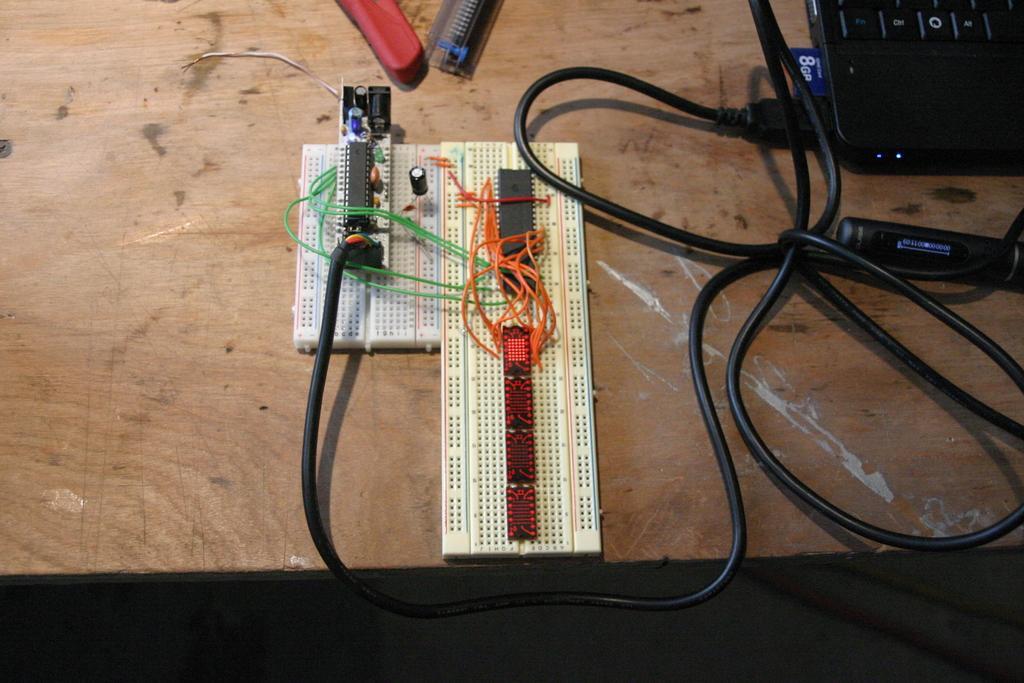How would you summarize this image in a sentence or two? In the center of this picture we can see the bread boards, wires, cable, laptop and some other objects are placed on the top of a wooden object which seems to be the table. 